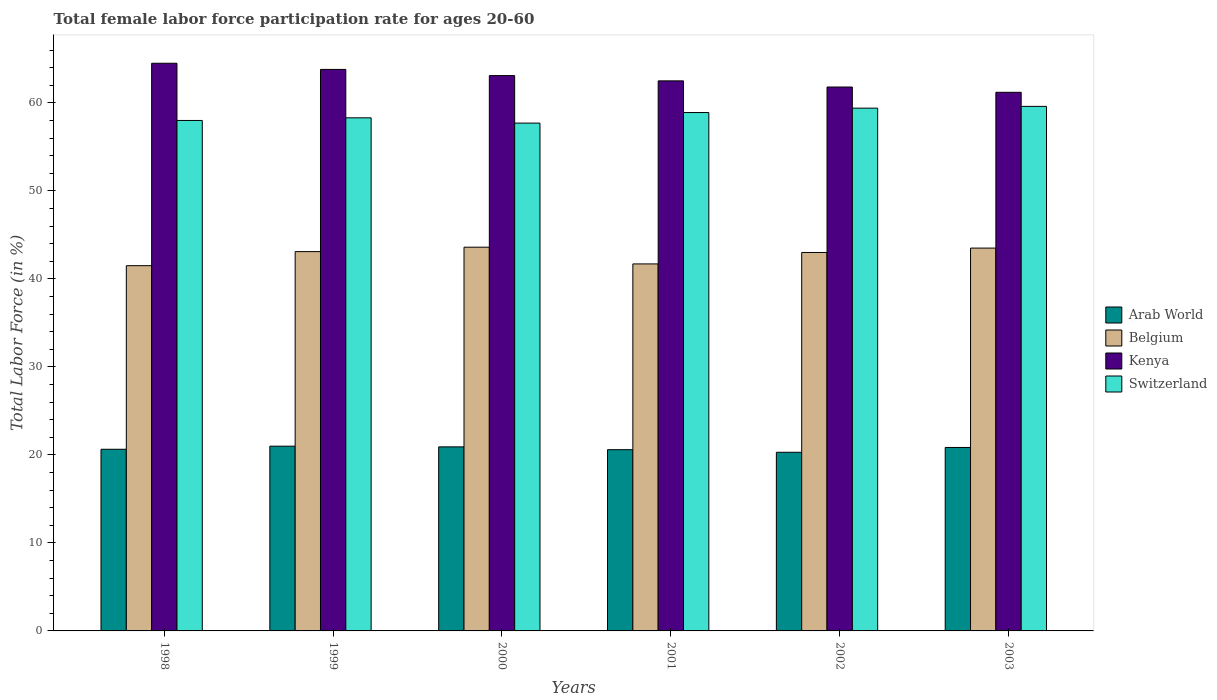How many groups of bars are there?
Your answer should be compact. 6. Are the number of bars per tick equal to the number of legend labels?
Your response must be concise. Yes. How many bars are there on the 2nd tick from the left?
Provide a short and direct response. 4. In how many cases, is the number of bars for a given year not equal to the number of legend labels?
Offer a terse response. 0. What is the female labor force participation rate in Belgium in 2000?
Keep it short and to the point. 43.6. Across all years, what is the maximum female labor force participation rate in Kenya?
Make the answer very short. 64.5. Across all years, what is the minimum female labor force participation rate in Belgium?
Your answer should be compact. 41.5. In which year was the female labor force participation rate in Arab World minimum?
Make the answer very short. 2002. What is the total female labor force participation rate in Kenya in the graph?
Give a very brief answer. 376.9. What is the difference between the female labor force participation rate in Arab World in 1998 and that in 2001?
Give a very brief answer. 0.05. What is the difference between the female labor force participation rate in Switzerland in 1998 and the female labor force participation rate in Kenya in 2002?
Provide a short and direct response. -3.8. What is the average female labor force participation rate in Belgium per year?
Provide a short and direct response. 42.73. In the year 1999, what is the difference between the female labor force participation rate in Kenya and female labor force participation rate in Arab World?
Provide a short and direct response. 42.81. What is the ratio of the female labor force participation rate in Switzerland in 1999 to that in 2001?
Your answer should be compact. 0.99. Is the female labor force participation rate in Arab World in 1998 less than that in 2000?
Make the answer very short. Yes. What is the difference between the highest and the second highest female labor force participation rate in Arab World?
Give a very brief answer. 0.08. What is the difference between the highest and the lowest female labor force participation rate in Arab World?
Your answer should be compact. 0.69. Is it the case that in every year, the sum of the female labor force participation rate in Arab World and female labor force participation rate in Switzerland is greater than the sum of female labor force participation rate in Belgium and female labor force participation rate in Kenya?
Keep it short and to the point. Yes. What does the 2nd bar from the left in 2003 represents?
Make the answer very short. Belgium. What does the 2nd bar from the right in 1999 represents?
Provide a succinct answer. Kenya. Are all the bars in the graph horizontal?
Your answer should be very brief. No. How many years are there in the graph?
Keep it short and to the point. 6. Are the values on the major ticks of Y-axis written in scientific E-notation?
Give a very brief answer. No. Does the graph contain any zero values?
Your answer should be compact. No. Does the graph contain grids?
Offer a very short reply. No. How many legend labels are there?
Keep it short and to the point. 4. How are the legend labels stacked?
Your answer should be very brief. Vertical. What is the title of the graph?
Provide a short and direct response. Total female labor force participation rate for ages 20-60. What is the label or title of the Y-axis?
Offer a very short reply. Total Labor Force (in %). What is the Total Labor Force (in %) in Arab World in 1998?
Provide a succinct answer. 20.64. What is the Total Labor Force (in %) of Belgium in 1998?
Ensure brevity in your answer.  41.5. What is the Total Labor Force (in %) in Kenya in 1998?
Your answer should be very brief. 64.5. What is the Total Labor Force (in %) in Switzerland in 1998?
Your answer should be very brief. 58. What is the Total Labor Force (in %) in Arab World in 1999?
Your response must be concise. 20.99. What is the Total Labor Force (in %) of Belgium in 1999?
Your answer should be compact. 43.1. What is the Total Labor Force (in %) of Kenya in 1999?
Provide a succinct answer. 63.8. What is the Total Labor Force (in %) of Switzerland in 1999?
Offer a very short reply. 58.3. What is the Total Labor Force (in %) of Arab World in 2000?
Offer a very short reply. 20.91. What is the Total Labor Force (in %) of Belgium in 2000?
Your answer should be very brief. 43.6. What is the Total Labor Force (in %) in Kenya in 2000?
Your response must be concise. 63.1. What is the Total Labor Force (in %) in Switzerland in 2000?
Provide a succinct answer. 57.7. What is the Total Labor Force (in %) of Arab World in 2001?
Give a very brief answer. 20.59. What is the Total Labor Force (in %) in Belgium in 2001?
Keep it short and to the point. 41.7. What is the Total Labor Force (in %) of Kenya in 2001?
Your response must be concise. 62.5. What is the Total Labor Force (in %) in Switzerland in 2001?
Provide a short and direct response. 58.9. What is the Total Labor Force (in %) in Arab World in 2002?
Your response must be concise. 20.3. What is the Total Labor Force (in %) of Kenya in 2002?
Offer a very short reply. 61.8. What is the Total Labor Force (in %) in Switzerland in 2002?
Offer a terse response. 59.4. What is the Total Labor Force (in %) of Arab World in 2003?
Offer a terse response. 20.85. What is the Total Labor Force (in %) of Belgium in 2003?
Provide a short and direct response. 43.5. What is the Total Labor Force (in %) of Kenya in 2003?
Your response must be concise. 61.2. What is the Total Labor Force (in %) of Switzerland in 2003?
Your response must be concise. 59.6. Across all years, what is the maximum Total Labor Force (in %) of Arab World?
Offer a very short reply. 20.99. Across all years, what is the maximum Total Labor Force (in %) of Belgium?
Your answer should be compact. 43.6. Across all years, what is the maximum Total Labor Force (in %) in Kenya?
Provide a short and direct response. 64.5. Across all years, what is the maximum Total Labor Force (in %) of Switzerland?
Your response must be concise. 59.6. Across all years, what is the minimum Total Labor Force (in %) in Arab World?
Keep it short and to the point. 20.3. Across all years, what is the minimum Total Labor Force (in %) in Belgium?
Keep it short and to the point. 41.5. Across all years, what is the minimum Total Labor Force (in %) of Kenya?
Offer a very short reply. 61.2. Across all years, what is the minimum Total Labor Force (in %) in Switzerland?
Provide a short and direct response. 57.7. What is the total Total Labor Force (in %) of Arab World in the graph?
Provide a short and direct response. 124.28. What is the total Total Labor Force (in %) in Belgium in the graph?
Make the answer very short. 256.4. What is the total Total Labor Force (in %) in Kenya in the graph?
Your answer should be very brief. 376.9. What is the total Total Labor Force (in %) of Switzerland in the graph?
Ensure brevity in your answer.  351.9. What is the difference between the Total Labor Force (in %) of Arab World in 1998 and that in 1999?
Make the answer very short. -0.35. What is the difference between the Total Labor Force (in %) in Belgium in 1998 and that in 1999?
Provide a succinct answer. -1.6. What is the difference between the Total Labor Force (in %) of Switzerland in 1998 and that in 1999?
Your answer should be very brief. -0.3. What is the difference between the Total Labor Force (in %) in Arab World in 1998 and that in 2000?
Provide a succinct answer. -0.27. What is the difference between the Total Labor Force (in %) in Switzerland in 1998 and that in 2000?
Your answer should be very brief. 0.3. What is the difference between the Total Labor Force (in %) of Arab World in 1998 and that in 2001?
Offer a terse response. 0.05. What is the difference between the Total Labor Force (in %) in Belgium in 1998 and that in 2001?
Provide a succinct answer. -0.2. What is the difference between the Total Labor Force (in %) in Switzerland in 1998 and that in 2001?
Offer a very short reply. -0.9. What is the difference between the Total Labor Force (in %) of Arab World in 1998 and that in 2002?
Give a very brief answer. 0.34. What is the difference between the Total Labor Force (in %) of Kenya in 1998 and that in 2002?
Provide a short and direct response. 2.7. What is the difference between the Total Labor Force (in %) of Arab World in 1998 and that in 2003?
Make the answer very short. -0.21. What is the difference between the Total Labor Force (in %) in Belgium in 1998 and that in 2003?
Your response must be concise. -2. What is the difference between the Total Labor Force (in %) in Kenya in 1998 and that in 2003?
Offer a terse response. 3.3. What is the difference between the Total Labor Force (in %) in Arab World in 1999 and that in 2000?
Give a very brief answer. 0.08. What is the difference between the Total Labor Force (in %) of Arab World in 1999 and that in 2001?
Ensure brevity in your answer.  0.4. What is the difference between the Total Labor Force (in %) in Kenya in 1999 and that in 2001?
Make the answer very short. 1.3. What is the difference between the Total Labor Force (in %) in Switzerland in 1999 and that in 2001?
Offer a terse response. -0.6. What is the difference between the Total Labor Force (in %) of Arab World in 1999 and that in 2002?
Offer a very short reply. 0.69. What is the difference between the Total Labor Force (in %) of Kenya in 1999 and that in 2002?
Your answer should be very brief. 2. What is the difference between the Total Labor Force (in %) in Arab World in 1999 and that in 2003?
Keep it short and to the point. 0.14. What is the difference between the Total Labor Force (in %) in Kenya in 1999 and that in 2003?
Give a very brief answer. 2.6. What is the difference between the Total Labor Force (in %) in Arab World in 2000 and that in 2001?
Make the answer very short. 0.32. What is the difference between the Total Labor Force (in %) in Belgium in 2000 and that in 2001?
Your response must be concise. 1.9. What is the difference between the Total Labor Force (in %) of Kenya in 2000 and that in 2001?
Your answer should be very brief. 0.6. What is the difference between the Total Labor Force (in %) of Arab World in 2000 and that in 2002?
Your answer should be very brief. 0.61. What is the difference between the Total Labor Force (in %) in Arab World in 2000 and that in 2003?
Your answer should be compact. 0.07. What is the difference between the Total Labor Force (in %) in Kenya in 2000 and that in 2003?
Your response must be concise. 1.9. What is the difference between the Total Labor Force (in %) of Switzerland in 2000 and that in 2003?
Make the answer very short. -1.9. What is the difference between the Total Labor Force (in %) of Arab World in 2001 and that in 2002?
Your response must be concise. 0.29. What is the difference between the Total Labor Force (in %) in Belgium in 2001 and that in 2002?
Offer a very short reply. -1.3. What is the difference between the Total Labor Force (in %) in Arab World in 2001 and that in 2003?
Your answer should be compact. -0.25. What is the difference between the Total Labor Force (in %) in Belgium in 2001 and that in 2003?
Your answer should be very brief. -1.8. What is the difference between the Total Labor Force (in %) in Switzerland in 2001 and that in 2003?
Keep it short and to the point. -0.7. What is the difference between the Total Labor Force (in %) in Arab World in 2002 and that in 2003?
Provide a succinct answer. -0.55. What is the difference between the Total Labor Force (in %) in Belgium in 2002 and that in 2003?
Keep it short and to the point. -0.5. What is the difference between the Total Labor Force (in %) of Kenya in 2002 and that in 2003?
Keep it short and to the point. 0.6. What is the difference between the Total Labor Force (in %) of Arab World in 1998 and the Total Labor Force (in %) of Belgium in 1999?
Give a very brief answer. -22.46. What is the difference between the Total Labor Force (in %) in Arab World in 1998 and the Total Labor Force (in %) in Kenya in 1999?
Give a very brief answer. -43.16. What is the difference between the Total Labor Force (in %) in Arab World in 1998 and the Total Labor Force (in %) in Switzerland in 1999?
Offer a very short reply. -37.66. What is the difference between the Total Labor Force (in %) of Belgium in 1998 and the Total Labor Force (in %) of Kenya in 1999?
Make the answer very short. -22.3. What is the difference between the Total Labor Force (in %) of Belgium in 1998 and the Total Labor Force (in %) of Switzerland in 1999?
Your answer should be compact. -16.8. What is the difference between the Total Labor Force (in %) of Arab World in 1998 and the Total Labor Force (in %) of Belgium in 2000?
Make the answer very short. -22.96. What is the difference between the Total Labor Force (in %) in Arab World in 1998 and the Total Labor Force (in %) in Kenya in 2000?
Your answer should be compact. -42.46. What is the difference between the Total Labor Force (in %) of Arab World in 1998 and the Total Labor Force (in %) of Switzerland in 2000?
Give a very brief answer. -37.06. What is the difference between the Total Labor Force (in %) in Belgium in 1998 and the Total Labor Force (in %) in Kenya in 2000?
Your answer should be very brief. -21.6. What is the difference between the Total Labor Force (in %) of Belgium in 1998 and the Total Labor Force (in %) of Switzerland in 2000?
Ensure brevity in your answer.  -16.2. What is the difference between the Total Labor Force (in %) in Kenya in 1998 and the Total Labor Force (in %) in Switzerland in 2000?
Your answer should be compact. 6.8. What is the difference between the Total Labor Force (in %) of Arab World in 1998 and the Total Labor Force (in %) of Belgium in 2001?
Provide a succinct answer. -21.06. What is the difference between the Total Labor Force (in %) of Arab World in 1998 and the Total Labor Force (in %) of Kenya in 2001?
Offer a very short reply. -41.86. What is the difference between the Total Labor Force (in %) of Arab World in 1998 and the Total Labor Force (in %) of Switzerland in 2001?
Your answer should be very brief. -38.26. What is the difference between the Total Labor Force (in %) in Belgium in 1998 and the Total Labor Force (in %) in Kenya in 2001?
Provide a succinct answer. -21. What is the difference between the Total Labor Force (in %) in Belgium in 1998 and the Total Labor Force (in %) in Switzerland in 2001?
Keep it short and to the point. -17.4. What is the difference between the Total Labor Force (in %) of Kenya in 1998 and the Total Labor Force (in %) of Switzerland in 2001?
Provide a short and direct response. 5.6. What is the difference between the Total Labor Force (in %) in Arab World in 1998 and the Total Labor Force (in %) in Belgium in 2002?
Offer a terse response. -22.36. What is the difference between the Total Labor Force (in %) of Arab World in 1998 and the Total Labor Force (in %) of Kenya in 2002?
Keep it short and to the point. -41.16. What is the difference between the Total Labor Force (in %) in Arab World in 1998 and the Total Labor Force (in %) in Switzerland in 2002?
Offer a very short reply. -38.76. What is the difference between the Total Labor Force (in %) in Belgium in 1998 and the Total Labor Force (in %) in Kenya in 2002?
Your answer should be compact. -20.3. What is the difference between the Total Labor Force (in %) in Belgium in 1998 and the Total Labor Force (in %) in Switzerland in 2002?
Offer a very short reply. -17.9. What is the difference between the Total Labor Force (in %) of Arab World in 1998 and the Total Labor Force (in %) of Belgium in 2003?
Your answer should be compact. -22.86. What is the difference between the Total Labor Force (in %) in Arab World in 1998 and the Total Labor Force (in %) in Kenya in 2003?
Offer a very short reply. -40.56. What is the difference between the Total Labor Force (in %) of Arab World in 1998 and the Total Labor Force (in %) of Switzerland in 2003?
Offer a terse response. -38.96. What is the difference between the Total Labor Force (in %) in Belgium in 1998 and the Total Labor Force (in %) in Kenya in 2003?
Give a very brief answer. -19.7. What is the difference between the Total Labor Force (in %) in Belgium in 1998 and the Total Labor Force (in %) in Switzerland in 2003?
Provide a short and direct response. -18.1. What is the difference between the Total Labor Force (in %) in Kenya in 1998 and the Total Labor Force (in %) in Switzerland in 2003?
Offer a terse response. 4.9. What is the difference between the Total Labor Force (in %) of Arab World in 1999 and the Total Labor Force (in %) of Belgium in 2000?
Your answer should be very brief. -22.61. What is the difference between the Total Labor Force (in %) of Arab World in 1999 and the Total Labor Force (in %) of Kenya in 2000?
Your response must be concise. -42.11. What is the difference between the Total Labor Force (in %) in Arab World in 1999 and the Total Labor Force (in %) in Switzerland in 2000?
Make the answer very short. -36.71. What is the difference between the Total Labor Force (in %) of Belgium in 1999 and the Total Labor Force (in %) of Switzerland in 2000?
Make the answer very short. -14.6. What is the difference between the Total Labor Force (in %) of Arab World in 1999 and the Total Labor Force (in %) of Belgium in 2001?
Your response must be concise. -20.71. What is the difference between the Total Labor Force (in %) in Arab World in 1999 and the Total Labor Force (in %) in Kenya in 2001?
Ensure brevity in your answer.  -41.51. What is the difference between the Total Labor Force (in %) of Arab World in 1999 and the Total Labor Force (in %) of Switzerland in 2001?
Provide a succinct answer. -37.91. What is the difference between the Total Labor Force (in %) of Belgium in 1999 and the Total Labor Force (in %) of Kenya in 2001?
Ensure brevity in your answer.  -19.4. What is the difference between the Total Labor Force (in %) of Belgium in 1999 and the Total Labor Force (in %) of Switzerland in 2001?
Provide a succinct answer. -15.8. What is the difference between the Total Labor Force (in %) in Kenya in 1999 and the Total Labor Force (in %) in Switzerland in 2001?
Offer a very short reply. 4.9. What is the difference between the Total Labor Force (in %) of Arab World in 1999 and the Total Labor Force (in %) of Belgium in 2002?
Your answer should be very brief. -22.01. What is the difference between the Total Labor Force (in %) in Arab World in 1999 and the Total Labor Force (in %) in Kenya in 2002?
Provide a succinct answer. -40.81. What is the difference between the Total Labor Force (in %) in Arab World in 1999 and the Total Labor Force (in %) in Switzerland in 2002?
Your answer should be very brief. -38.41. What is the difference between the Total Labor Force (in %) in Belgium in 1999 and the Total Labor Force (in %) in Kenya in 2002?
Keep it short and to the point. -18.7. What is the difference between the Total Labor Force (in %) of Belgium in 1999 and the Total Labor Force (in %) of Switzerland in 2002?
Provide a succinct answer. -16.3. What is the difference between the Total Labor Force (in %) of Arab World in 1999 and the Total Labor Force (in %) of Belgium in 2003?
Your response must be concise. -22.51. What is the difference between the Total Labor Force (in %) of Arab World in 1999 and the Total Labor Force (in %) of Kenya in 2003?
Make the answer very short. -40.21. What is the difference between the Total Labor Force (in %) of Arab World in 1999 and the Total Labor Force (in %) of Switzerland in 2003?
Your response must be concise. -38.61. What is the difference between the Total Labor Force (in %) in Belgium in 1999 and the Total Labor Force (in %) in Kenya in 2003?
Offer a very short reply. -18.1. What is the difference between the Total Labor Force (in %) in Belgium in 1999 and the Total Labor Force (in %) in Switzerland in 2003?
Your answer should be compact. -16.5. What is the difference between the Total Labor Force (in %) of Arab World in 2000 and the Total Labor Force (in %) of Belgium in 2001?
Give a very brief answer. -20.79. What is the difference between the Total Labor Force (in %) in Arab World in 2000 and the Total Labor Force (in %) in Kenya in 2001?
Make the answer very short. -41.59. What is the difference between the Total Labor Force (in %) in Arab World in 2000 and the Total Labor Force (in %) in Switzerland in 2001?
Give a very brief answer. -37.99. What is the difference between the Total Labor Force (in %) of Belgium in 2000 and the Total Labor Force (in %) of Kenya in 2001?
Offer a very short reply. -18.9. What is the difference between the Total Labor Force (in %) in Belgium in 2000 and the Total Labor Force (in %) in Switzerland in 2001?
Make the answer very short. -15.3. What is the difference between the Total Labor Force (in %) of Kenya in 2000 and the Total Labor Force (in %) of Switzerland in 2001?
Provide a succinct answer. 4.2. What is the difference between the Total Labor Force (in %) of Arab World in 2000 and the Total Labor Force (in %) of Belgium in 2002?
Ensure brevity in your answer.  -22.09. What is the difference between the Total Labor Force (in %) in Arab World in 2000 and the Total Labor Force (in %) in Kenya in 2002?
Offer a very short reply. -40.89. What is the difference between the Total Labor Force (in %) in Arab World in 2000 and the Total Labor Force (in %) in Switzerland in 2002?
Ensure brevity in your answer.  -38.49. What is the difference between the Total Labor Force (in %) in Belgium in 2000 and the Total Labor Force (in %) in Kenya in 2002?
Provide a succinct answer. -18.2. What is the difference between the Total Labor Force (in %) of Belgium in 2000 and the Total Labor Force (in %) of Switzerland in 2002?
Offer a terse response. -15.8. What is the difference between the Total Labor Force (in %) in Arab World in 2000 and the Total Labor Force (in %) in Belgium in 2003?
Make the answer very short. -22.59. What is the difference between the Total Labor Force (in %) of Arab World in 2000 and the Total Labor Force (in %) of Kenya in 2003?
Keep it short and to the point. -40.29. What is the difference between the Total Labor Force (in %) in Arab World in 2000 and the Total Labor Force (in %) in Switzerland in 2003?
Give a very brief answer. -38.69. What is the difference between the Total Labor Force (in %) in Belgium in 2000 and the Total Labor Force (in %) in Kenya in 2003?
Ensure brevity in your answer.  -17.6. What is the difference between the Total Labor Force (in %) in Kenya in 2000 and the Total Labor Force (in %) in Switzerland in 2003?
Your answer should be compact. 3.5. What is the difference between the Total Labor Force (in %) in Arab World in 2001 and the Total Labor Force (in %) in Belgium in 2002?
Give a very brief answer. -22.41. What is the difference between the Total Labor Force (in %) of Arab World in 2001 and the Total Labor Force (in %) of Kenya in 2002?
Give a very brief answer. -41.21. What is the difference between the Total Labor Force (in %) of Arab World in 2001 and the Total Labor Force (in %) of Switzerland in 2002?
Your response must be concise. -38.81. What is the difference between the Total Labor Force (in %) in Belgium in 2001 and the Total Labor Force (in %) in Kenya in 2002?
Keep it short and to the point. -20.1. What is the difference between the Total Labor Force (in %) of Belgium in 2001 and the Total Labor Force (in %) of Switzerland in 2002?
Your response must be concise. -17.7. What is the difference between the Total Labor Force (in %) in Arab World in 2001 and the Total Labor Force (in %) in Belgium in 2003?
Your answer should be very brief. -22.91. What is the difference between the Total Labor Force (in %) in Arab World in 2001 and the Total Labor Force (in %) in Kenya in 2003?
Offer a very short reply. -40.61. What is the difference between the Total Labor Force (in %) in Arab World in 2001 and the Total Labor Force (in %) in Switzerland in 2003?
Offer a very short reply. -39.01. What is the difference between the Total Labor Force (in %) of Belgium in 2001 and the Total Labor Force (in %) of Kenya in 2003?
Provide a succinct answer. -19.5. What is the difference between the Total Labor Force (in %) of Belgium in 2001 and the Total Labor Force (in %) of Switzerland in 2003?
Give a very brief answer. -17.9. What is the difference between the Total Labor Force (in %) of Kenya in 2001 and the Total Labor Force (in %) of Switzerland in 2003?
Make the answer very short. 2.9. What is the difference between the Total Labor Force (in %) of Arab World in 2002 and the Total Labor Force (in %) of Belgium in 2003?
Your answer should be compact. -23.2. What is the difference between the Total Labor Force (in %) in Arab World in 2002 and the Total Labor Force (in %) in Kenya in 2003?
Provide a succinct answer. -40.9. What is the difference between the Total Labor Force (in %) of Arab World in 2002 and the Total Labor Force (in %) of Switzerland in 2003?
Ensure brevity in your answer.  -39.3. What is the difference between the Total Labor Force (in %) of Belgium in 2002 and the Total Labor Force (in %) of Kenya in 2003?
Your answer should be very brief. -18.2. What is the difference between the Total Labor Force (in %) in Belgium in 2002 and the Total Labor Force (in %) in Switzerland in 2003?
Keep it short and to the point. -16.6. What is the difference between the Total Labor Force (in %) in Kenya in 2002 and the Total Labor Force (in %) in Switzerland in 2003?
Your answer should be compact. 2.2. What is the average Total Labor Force (in %) of Arab World per year?
Ensure brevity in your answer.  20.71. What is the average Total Labor Force (in %) in Belgium per year?
Offer a terse response. 42.73. What is the average Total Labor Force (in %) of Kenya per year?
Ensure brevity in your answer.  62.82. What is the average Total Labor Force (in %) in Switzerland per year?
Give a very brief answer. 58.65. In the year 1998, what is the difference between the Total Labor Force (in %) of Arab World and Total Labor Force (in %) of Belgium?
Make the answer very short. -20.86. In the year 1998, what is the difference between the Total Labor Force (in %) in Arab World and Total Labor Force (in %) in Kenya?
Ensure brevity in your answer.  -43.86. In the year 1998, what is the difference between the Total Labor Force (in %) in Arab World and Total Labor Force (in %) in Switzerland?
Make the answer very short. -37.36. In the year 1998, what is the difference between the Total Labor Force (in %) in Belgium and Total Labor Force (in %) in Kenya?
Offer a very short reply. -23. In the year 1998, what is the difference between the Total Labor Force (in %) of Belgium and Total Labor Force (in %) of Switzerland?
Your answer should be very brief. -16.5. In the year 1998, what is the difference between the Total Labor Force (in %) of Kenya and Total Labor Force (in %) of Switzerland?
Your response must be concise. 6.5. In the year 1999, what is the difference between the Total Labor Force (in %) in Arab World and Total Labor Force (in %) in Belgium?
Your answer should be compact. -22.11. In the year 1999, what is the difference between the Total Labor Force (in %) of Arab World and Total Labor Force (in %) of Kenya?
Your response must be concise. -42.81. In the year 1999, what is the difference between the Total Labor Force (in %) of Arab World and Total Labor Force (in %) of Switzerland?
Your response must be concise. -37.31. In the year 1999, what is the difference between the Total Labor Force (in %) in Belgium and Total Labor Force (in %) in Kenya?
Your answer should be compact. -20.7. In the year 1999, what is the difference between the Total Labor Force (in %) of Belgium and Total Labor Force (in %) of Switzerland?
Offer a terse response. -15.2. In the year 1999, what is the difference between the Total Labor Force (in %) of Kenya and Total Labor Force (in %) of Switzerland?
Make the answer very short. 5.5. In the year 2000, what is the difference between the Total Labor Force (in %) in Arab World and Total Labor Force (in %) in Belgium?
Offer a terse response. -22.69. In the year 2000, what is the difference between the Total Labor Force (in %) in Arab World and Total Labor Force (in %) in Kenya?
Keep it short and to the point. -42.19. In the year 2000, what is the difference between the Total Labor Force (in %) of Arab World and Total Labor Force (in %) of Switzerland?
Your answer should be very brief. -36.79. In the year 2000, what is the difference between the Total Labor Force (in %) of Belgium and Total Labor Force (in %) of Kenya?
Give a very brief answer. -19.5. In the year 2000, what is the difference between the Total Labor Force (in %) of Belgium and Total Labor Force (in %) of Switzerland?
Give a very brief answer. -14.1. In the year 2000, what is the difference between the Total Labor Force (in %) in Kenya and Total Labor Force (in %) in Switzerland?
Ensure brevity in your answer.  5.4. In the year 2001, what is the difference between the Total Labor Force (in %) of Arab World and Total Labor Force (in %) of Belgium?
Your response must be concise. -21.11. In the year 2001, what is the difference between the Total Labor Force (in %) of Arab World and Total Labor Force (in %) of Kenya?
Your answer should be compact. -41.91. In the year 2001, what is the difference between the Total Labor Force (in %) of Arab World and Total Labor Force (in %) of Switzerland?
Give a very brief answer. -38.31. In the year 2001, what is the difference between the Total Labor Force (in %) in Belgium and Total Labor Force (in %) in Kenya?
Your response must be concise. -20.8. In the year 2001, what is the difference between the Total Labor Force (in %) in Belgium and Total Labor Force (in %) in Switzerland?
Offer a terse response. -17.2. In the year 2002, what is the difference between the Total Labor Force (in %) in Arab World and Total Labor Force (in %) in Belgium?
Your answer should be compact. -22.7. In the year 2002, what is the difference between the Total Labor Force (in %) of Arab World and Total Labor Force (in %) of Kenya?
Your answer should be compact. -41.5. In the year 2002, what is the difference between the Total Labor Force (in %) in Arab World and Total Labor Force (in %) in Switzerland?
Your answer should be very brief. -39.1. In the year 2002, what is the difference between the Total Labor Force (in %) in Belgium and Total Labor Force (in %) in Kenya?
Offer a very short reply. -18.8. In the year 2002, what is the difference between the Total Labor Force (in %) of Belgium and Total Labor Force (in %) of Switzerland?
Provide a succinct answer. -16.4. In the year 2002, what is the difference between the Total Labor Force (in %) of Kenya and Total Labor Force (in %) of Switzerland?
Your response must be concise. 2.4. In the year 2003, what is the difference between the Total Labor Force (in %) in Arab World and Total Labor Force (in %) in Belgium?
Provide a short and direct response. -22.65. In the year 2003, what is the difference between the Total Labor Force (in %) in Arab World and Total Labor Force (in %) in Kenya?
Provide a short and direct response. -40.35. In the year 2003, what is the difference between the Total Labor Force (in %) in Arab World and Total Labor Force (in %) in Switzerland?
Give a very brief answer. -38.75. In the year 2003, what is the difference between the Total Labor Force (in %) in Belgium and Total Labor Force (in %) in Kenya?
Your response must be concise. -17.7. In the year 2003, what is the difference between the Total Labor Force (in %) in Belgium and Total Labor Force (in %) in Switzerland?
Your answer should be compact. -16.1. In the year 2003, what is the difference between the Total Labor Force (in %) of Kenya and Total Labor Force (in %) of Switzerland?
Your response must be concise. 1.6. What is the ratio of the Total Labor Force (in %) of Arab World in 1998 to that in 1999?
Provide a short and direct response. 0.98. What is the ratio of the Total Labor Force (in %) of Belgium in 1998 to that in 1999?
Make the answer very short. 0.96. What is the ratio of the Total Labor Force (in %) of Switzerland in 1998 to that in 1999?
Make the answer very short. 0.99. What is the ratio of the Total Labor Force (in %) of Arab World in 1998 to that in 2000?
Your answer should be compact. 0.99. What is the ratio of the Total Labor Force (in %) of Belgium in 1998 to that in 2000?
Offer a very short reply. 0.95. What is the ratio of the Total Labor Force (in %) in Kenya in 1998 to that in 2000?
Give a very brief answer. 1.02. What is the ratio of the Total Labor Force (in %) in Kenya in 1998 to that in 2001?
Your response must be concise. 1.03. What is the ratio of the Total Labor Force (in %) of Switzerland in 1998 to that in 2001?
Your response must be concise. 0.98. What is the ratio of the Total Labor Force (in %) in Arab World in 1998 to that in 2002?
Offer a very short reply. 1.02. What is the ratio of the Total Labor Force (in %) of Belgium in 1998 to that in 2002?
Provide a succinct answer. 0.97. What is the ratio of the Total Labor Force (in %) in Kenya in 1998 to that in 2002?
Your answer should be very brief. 1.04. What is the ratio of the Total Labor Force (in %) in Switzerland in 1998 to that in 2002?
Keep it short and to the point. 0.98. What is the ratio of the Total Labor Force (in %) in Arab World in 1998 to that in 2003?
Ensure brevity in your answer.  0.99. What is the ratio of the Total Labor Force (in %) of Belgium in 1998 to that in 2003?
Offer a very short reply. 0.95. What is the ratio of the Total Labor Force (in %) of Kenya in 1998 to that in 2003?
Make the answer very short. 1.05. What is the ratio of the Total Labor Force (in %) in Switzerland in 1998 to that in 2003?
Provide a succinct answer. 0.97. What is the ratio of the Total Labor Force (in %) in Belgium in 1999 to that in 2000?
Give a very brief answer. 0.99. What is the ratio of the Total Labor Force (in %) in Kenya in 1999 to that in 2000?
Make the answer very short. 1.01. What is the ratio of the Total Labor Force (in %) in Switzerland in 1999 to that in 2000?
Make the answer very short. 1.01. What is the ratio of the Total Labor Force (in %) of Arab World in 1999 to that in 2001?
Offer a terse response. 1.02. What is the ratio of the Total Labor Force (in %) of Belgium in 1999 to that in 2001?
Ensure brevity in your answer.  1.03. What is the ratio of the Total Labor Force (in %) of Kenya in 1999 to that in 2001?
Your response must be concise. 1.02. What is the ratio of the Total Labor Force (in %) of Switzerland in 1999 to that in 2001?
Give a very brief answer. 0.99. What is the ratio of the Total Labor Force (in %) of Arab World in 1999 to that in 2002?
Make the answer very short. 1.03. What is the ratio of the Total Labor Force (in %) in Kenya in 1999 to that in 2002?
Provide a short and direct response. 1.03. What is the ratio of the Total Labor Force (in %) of Switzerland in 1999 to that in 2002?
Your answer should be very brief. 0.98. What is the ratio of the Total Labor Force (in %) in Kenya in 1999 to that in 2003?
Provide a succinct answer. 1.04. What is the ratio of the Total Labor Force (in %) in Switzerland in 1999 to that in 2003?
Your answer should be very brief. 0.98. What is the ratio of the Total Labor Force (in %) in Arab World in 2000 to that in 2001?
Provide a short and direct response. 1.02. What is the ratio of the Total Labor Force (in %) in Belgium in 2000 to that in 2001?
Provide a short and direct response. 1.05. What is the ratio of the Total Labor Force (in %) in Kenya in 2000 to that in 2001?
Keep it short and to the point. 1.01. What is the ratio of the Total Labor Force (in %) of Switzerland in 2000 to that in 2001?
Provide a short and direct response. 0.98. What is the ratio of the Total Labor Force (in %) in Arab World in 2000 to that in 2002?
Offer a very short reply. 1.03. What is the ratio of the Total Labor Force (in %) of Switzerland in 2000 to that in 2002?
Provide a succinct answer. 0.97. What is the ratio of the Total Labor Force (in %) of Kenya in 2000 to that in 2003?
Keep it short and to the point. 1.03. What is the ratio of the Total Labor Force (in %) in Switzerland in 2000 to that in 2003?
Provide a succinct answer. 0.97. What is the ratio of the Total Labor Force (in %) in Arab World in 2001 to that in 2002?
Offer a terse response. 1.01. What is the ratio of the Total Labor Force (in %) in Belgium in 2001 to that in 2002?
Provide a succinct answer. 0.97. What is the ratio of the Total Labor Force (in %) in Kenya in 2001 to that in 2002?
Offer a very short reply. 1.01. What is the ratio of the Total Labor Force (in %) in Arab World in 2001 to that in 2003?
Make the answer very short. 0.99. What is the ratio of the Total Labor Force (in %) in Belgium in 2001 to that in 2003?
Provide a short and direct response. 0.96. What is the ratio of the Total Labor Force (in %) in Kenya in 2001 to that in 2003?
Offer a very short reply. 1.02. What is the ratio of the Total Labor Force (in %) of Switzerland in 2001 to that in 2003?
Your response must be concise. 0.99. What is the ratio of the Total Labor Force (in %) in Arab World in 2002 to that in 2003?
Ensure brevity in your answer.  0.97. What is the ratio of the Total Labor Force (in %) in Kenya in 2002 to that in 2003?
Keep it short and to the point. 1.01. What is the difference between the highest and the second highest Total Labor Force (in %) of Arab World?
Provide a short and direct response. 0.08. What is the difference between the highest and the second highest Total Labor Force (in %) of Kenya?
Ensure brevity in your answer.  0.7. What is the difference between the highest and the second highest Total Labor Force (in %) in Switzerland?
Your response must be concise. 0.2. What is the difference between the highest and the lowest Total Labor Force (in %) in Arab World?
Provide a short and direct response. 0.69. What is the difference between the highest and the lowest Total Labor Force (in %) in Belgium?
Your answer should be compact. 2.1. What is the difference between the highest and the lowest Total Labor Force (in %) of Kenya?
Your answer should be very brief. 3.3. 